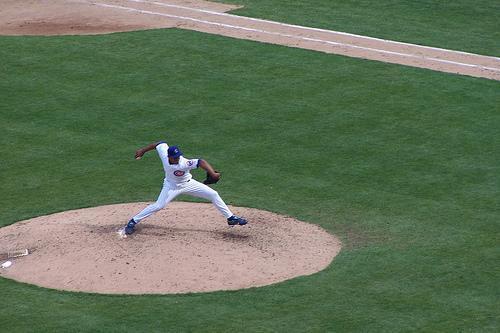How many cheerleaders are to the right of the baseball player?
Give a very brief answer. 0. 